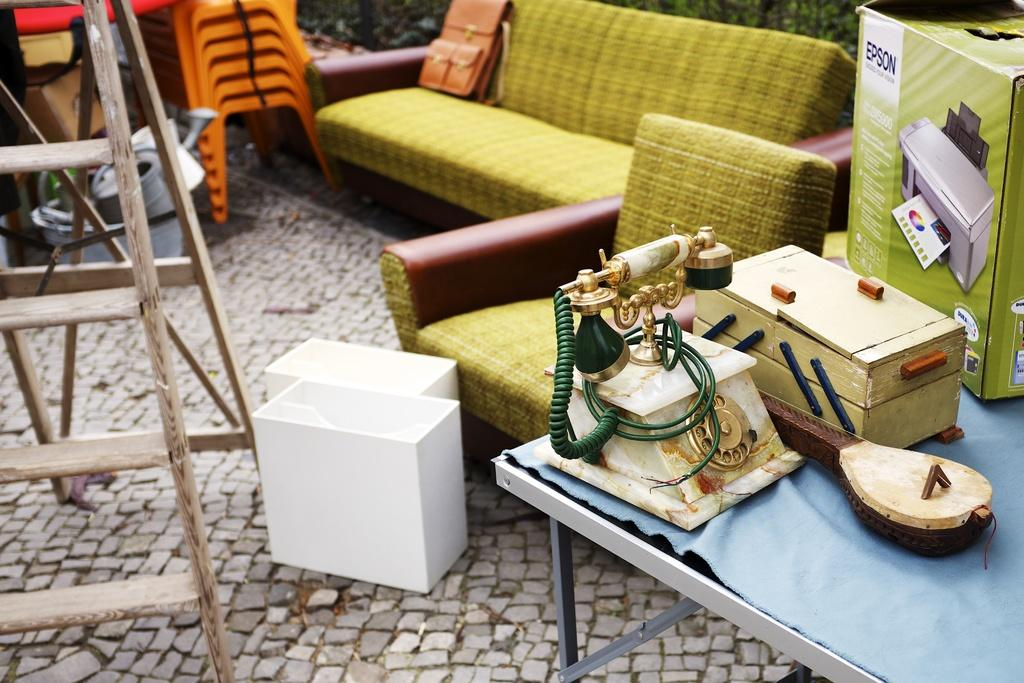What communication device is visible in the image? There is a telephone in the image. What type of furniture can be seen in the image? There is a couch in the image. What is placed on the couch? A bag is on the couch. What type of seating is available in the image? There are chairs in the image. What device is used for printing in the image? There is a printer in the image. What type of container is present in the image? There is a cardboard box in the image. Can you tell me how many firemen are present in the image? There are no firemen present in the image. What type of spark can be seen coming from the printer in the image? There is no spark present in the image, and the printer is not shown to be in operation. 